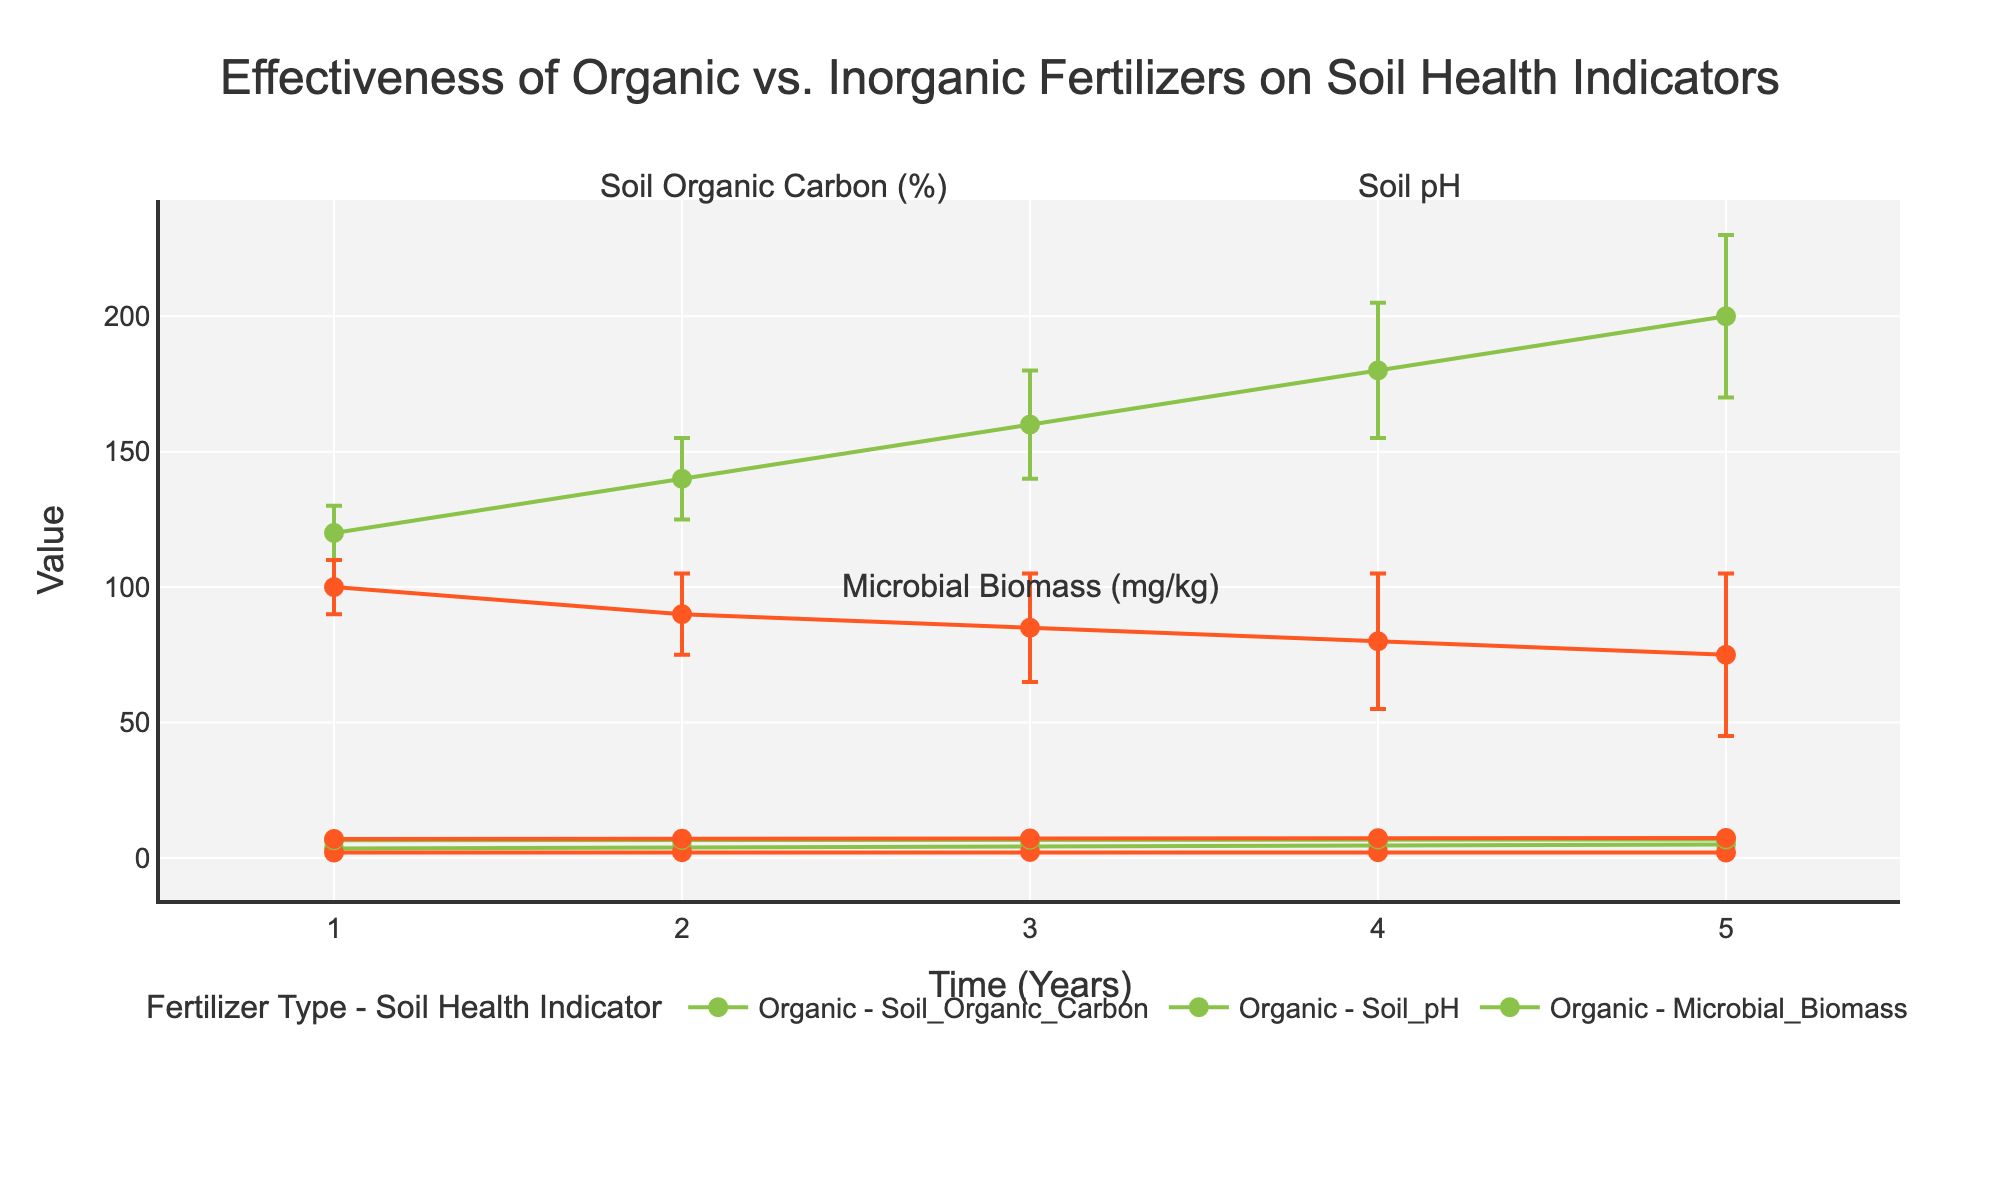What is the title of the plot? The title of the plot is usually positioned at the top center of the figure, often in larger and bold font compared to other text elements.
Answer: Effectiveness of Organic vs. Inorganic Fertilizers on Soil Health Indicators How many time points (years) are displayed on the x-axis? The x-axis displays the time intervals in years. Counting the distinct points along the x-axis will give the answer.
Answer: 5 What is the mean value of Soil Organic Carbon for Organic fertilizer in the first year? Locate the data point for Organic fertilizer on the Soil Organic Carbon indicator at the first time point (year 1), then read off the mean value.
Answer: 3.5 Which fertilizer type shows greater microbial biomass in the final year, and by how much? Compare the microbial biomass mean value for Organic and Inorganic fertilizers at year 5. Organic is 200 while Inorganic is 75. The difference is found by subtracting the smaller value from the larger value.
Answer: Organic, 125 How does the Soil pH change over time with Organic fertilizer application? Observe the trend of Soil pH values at each time point for Organic fertilizer, noting whether it increases, decreases, or remains constant.
Answer: Increases gradually Which fertilizer type has the higher Soil Organic Carbon mean value consistently over time? Compare the Soil Organic Carbon mean values of both fertilizers at each time point from years 1 to 5. Organic fertilizer consistently has higher values.
Answer: Organic What is the standard error range for Inorganic fertilizer's Soil pH at year 4? The standard error range can be found by adding and subtracting the standard error from the mean value for Soil pH with Inorganic fertilizer at year 4. (Mean ± Standard Error = 7.3 ± 0.2)
Answer: 7.1 to 7.5 By how much does the mean value of Soil Organic Carbon with Organic fertilizer change from year 2 to year 3? Subtract the mean value at year 2 from the mean value at year 3 for Soil Organic Carbon under Organic fertilizer (4.5 - 4.0).
Answer: 0.5 What visual elements are used to display the error bars in the plot? Error bars are represented as vertical lines extending above and below the data points, depicting variability around the mean values. This information can be seen by observing how uncertainty is represented in the plot.
Answer: Vertical lines What is the trend in microbial biomass for Inorganic fertilizer after the first year? Examine the data points for microbial biomass under Inorganic fertilizer from year 1 onwards and note whether the values increase, decrease, or remain stable.
Answer: Decreases over time 